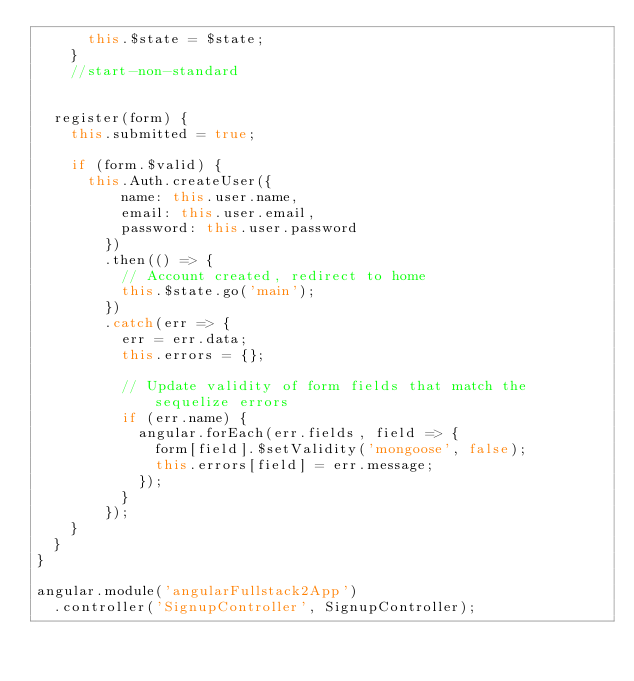Convert code to text. <code><loc_0><loc_0><loc_500><loc_500><_JavaScript_>      this.$state = $state;
    }
    //start-non-standard


  register(form) {
    this.submitted = true;

    if (form.$valid) {
      this.Auth.createUser({
          name: this.user.name,
          email: this.user.email,
          password: this.user.password
        })
        .then(() => {
          // Account created, redirect to home
          this.$state.go('main');
        })
        .catch(err => {
          err = err.data;
          this.errors = {};

          // Update validity of form fields that match the sequelize errors
          if (err.name) {
            angular.forEach(err.fields, field => {
              form[field].$setValidity('mongoose', false);
              this.errors[field] = err.message;
            });
          }
        });
    }
  }
}

angular.module('angularFullstack2App')
  .controller('SignupController', SignupController);
</code> 